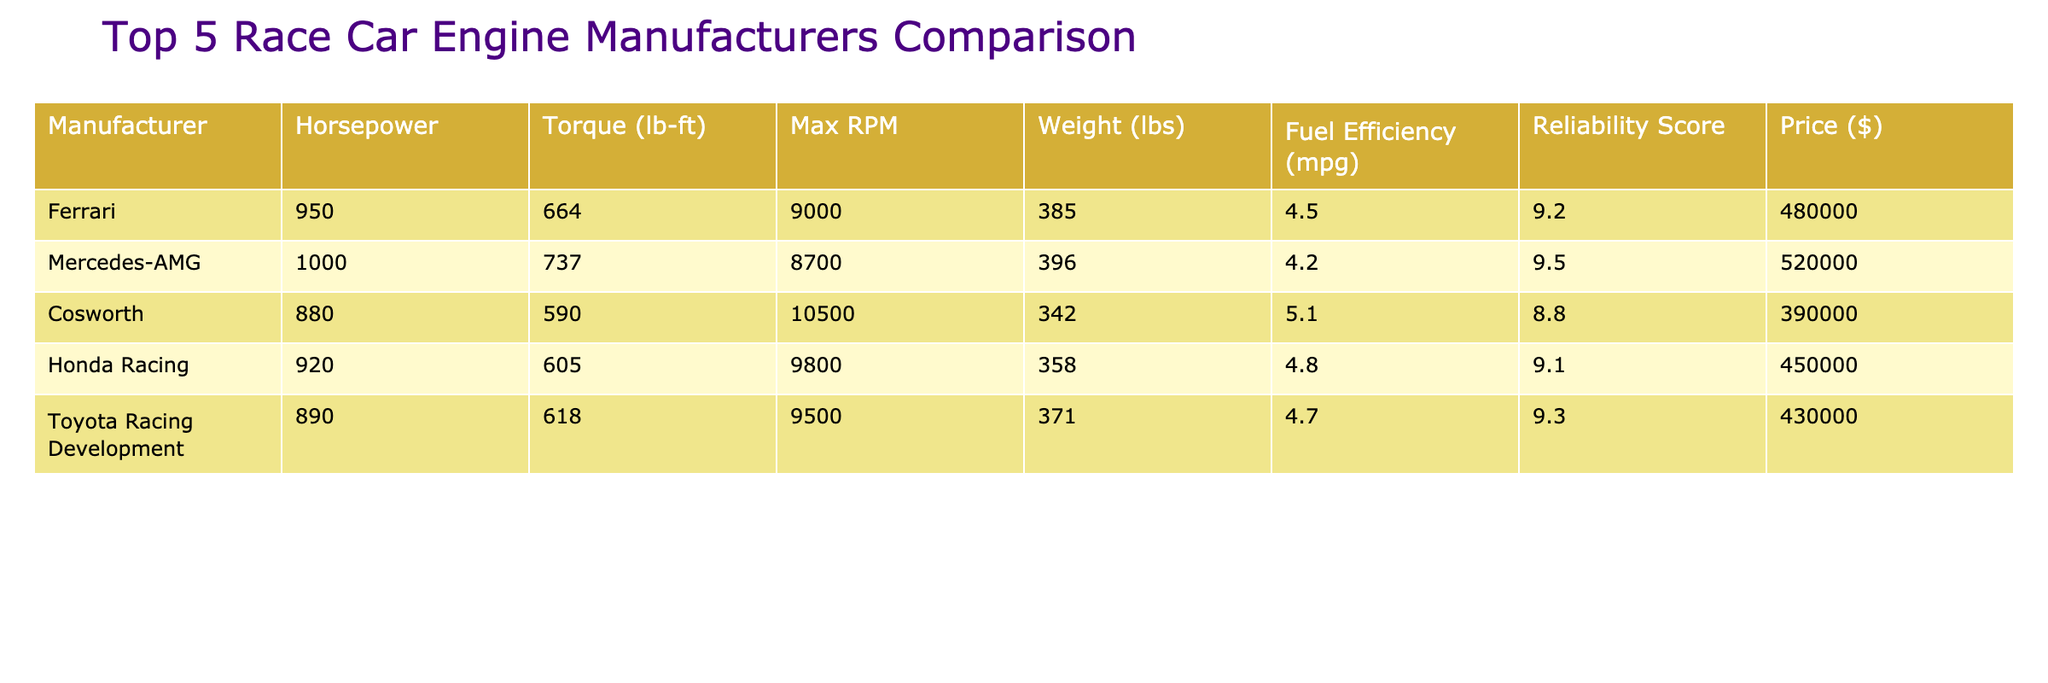What is the horsepower of the Mercedes-AMG engine? Looking at the table under the "Horsepower" column for "Mercedes-AMG," the value listed is 1000.
Answer: 1000 Which manufacturer has the highest torque? By comparing the "Torque (lb-ft)" values, we see that Mercedes-AMG has the highest torque at 737 lb-ft.
Answer: Mercedes-AMG What is the average max RPM of the engines? To find the average max RPM, we add up the values: (9000 + 8700 + 10500 + 9800 + 9500) = 50000. Then, divide by the number of manufacturers, which is 5. So, the average max RPM is 50000 / 5 = 10000.
Answer: 10000 Is the fuel efficiency of the Cosworth engine greater than 5 mpg? Looking into the "Fuel Efficiency (mpg)" column, Cosworth has a value of 5.1 mpg, which is indeed greater than 5 mpg.
Answer: Yes What is the price difference between Ferrari and Toyota Racing Development engines? The price of Ferrari is 480000 and that of Toyota Racing Development is 430000. The difference is 480000 - 430000 = 50000.
Answer: 50000 Which manufacturer has both the highest horsepower and the highest reliability score? Upon checking, Mercedes-AMG has the highest horsepower (1000) and also a high reliability score of 9.5. Other manufacturers do not meet this criteria.
Answer: Mercedes-AMG What is the total weight of all the engines combined? Adding the weights from the "Weight (lbs)" column gives us: (385 + 396 + 342 + 358 + 371) = 1852 lbs for all the engines combined.
Answer: 1852 Is the Honda Racing engine more reliable than the Ferrari engine? The reliability score for Honda Racing is 9.1 while for Ferrari it is 9.2. Since 9.1 is less than 9.2, Honda Racing is not more reliable than Ferrari.
Answer: No Which engine has the least torque and what is its value? The torque values indicate that Cosworth has the least torque at 590 lb-ft, as confirmed by locating it in the "Torque (lb-ft)" column.
Answer: 590 